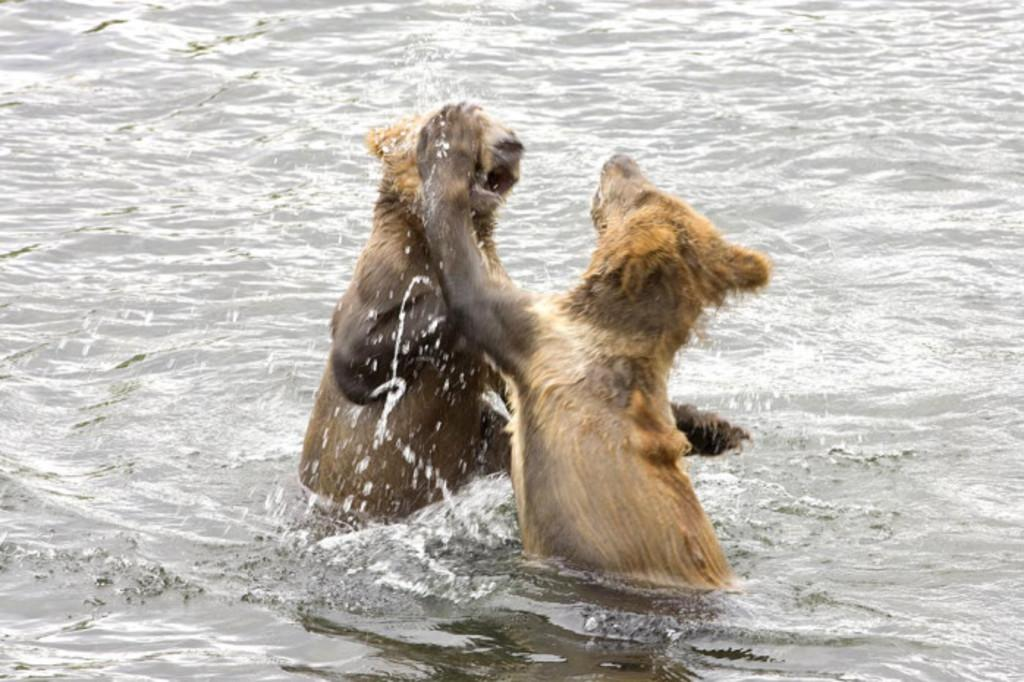How many animals are present in the image? There are two animals in the image. Where are the animals located? The animals are in the water. What type of pump is being used by the animals in the image? There is no pump present in the image; the animals are simply in the water. 